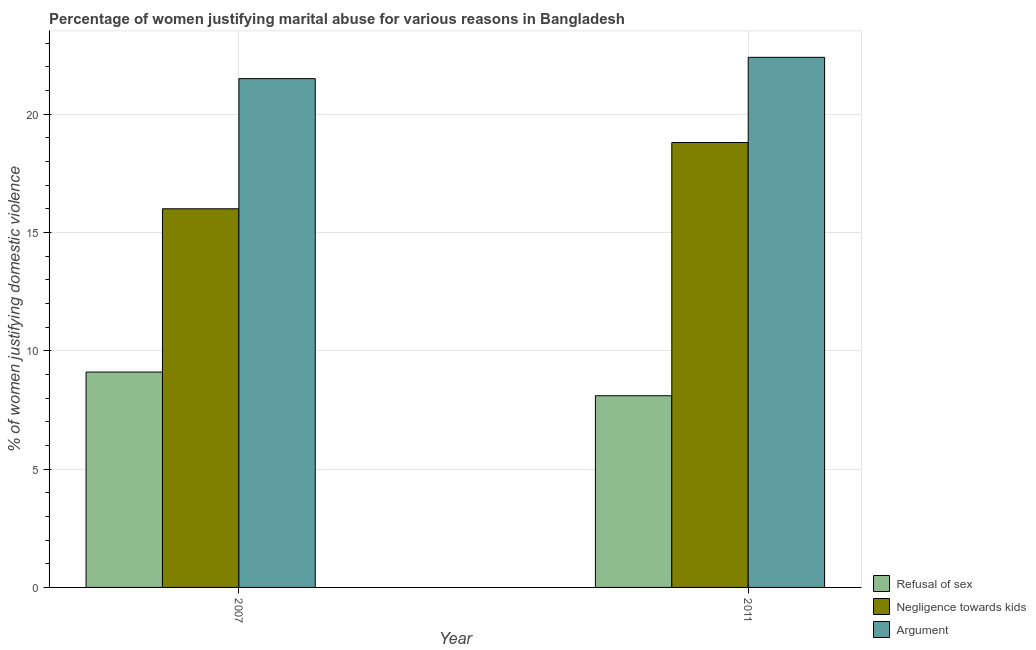How many different coloured bars are there?
Keep it short and to the point. 3. Are the number of bars on each tick of the X-axis equal?
Offer a terse response. Yes. What is the percentage of women justifying domestic violence due to arguments in 2007?
Ensure brevity in your answer.  21.5. Across all years, what is the maximum percentage of women justifying domestic violence due to arguments?
Keep it short and to the point. 22.4. Across all years, what is the minimum percentage of women justifying domestic violence due to negligence towards kids?
Your response must be concise. 16. In which year was the percentage of women justifying domestic violence due to refusal of sex maximum?
Offer a terse response. 2007. In which year was the percentage of women justifying domestic violence due to arguments minimum?
Keep it short and to the point. 2007. What is the total percentage of women justifying domestic violence due to negligence towards kids in the graph?
Give a very brief answer. 34.8. What is the difference between the percentage of women justifying domestic violence due to arguments in 2007 and that in 2011?
Your answer should be compact. -0.9. What is the difference between the percentage of women justifying domestic violence due to arguments in 2007 and the percentage of women justifying domestic violence due to negligence towards kids in 2011?
Your response must be concise. -0.9. In how many years, is the percentage of women justifying domestic violence due to negligence towards kids greater than 1 %?
Your answer should be very brief. 2. What is the ratio of the percentage of women justifying domestic violence due to refusal of sex in 2007 to that in 2011?
Provide a short and direct response. 1.12. Is the percentage of women justifying domestic violence due to negligence towards kids in 2007 less than that in 2011?
Offer a very short reply. Yes. What does the 3rd bar from the left in 2011 represents?
Ensure brevity in your answer.  Argument. What does the 1st bar from the right in 2011 represents?
Your answer should be very brief. Argument. How many bars are there?
Your response must be concise. 6. How many years are there in the graph?
Give a very brief answer. 2. What is the difference between two consecutive major ticks on the Y-axis?
Provide a succinct answer. 5. Are the values on the major ticks of Y-axis written in scientific E-notation?
Keep it short and to the point. No. Does the graph contain grids?
Make the answer very short. Yes. What is the title of the graph?
Offer a terse response. Percentage of women justifying marital abuse for various reasons in Bangladesh. Does "Female employers" appear as one of the legend labels in the graph?
Your answer should be compact. No. What is the label or title of the Y-axis?
Make the answer very short. % of women justifying domestic violence. What is the % of women justifying domestic violence in Negligence towards kids in 2007?
Ensure brevity in your answer.  16. What is the % of women justifying domestic violence in Argument in 2007?
Give a very brief answer. 21.5. What is the % of women justifying domestic violence in Argument in 2011?
Provide a succinct answer. 22.4. Across all years, what is the maximum % of women justifying domestic violence of Argument?
Your response must be concise. 22.4. Across all years, what is the minimum % of women justifying domestic violence in Refusal of sex?
Provide a short and direct response. 8.1. What is the total % of women justifying domestic violence in Negligence towards kids in the graph?
Make the answer very short. 34.8. What is the total % of women justifying domestic violence in Argument in the graph?
Give a very brief answer. 43.9. What is the difference between the % of women justifying domestic violence of Refusal of sex in 2007 and that in 2011?
Your answer should be very brief. 1. What is the difference between the % of women justifying domestic violence in Negligence towards kids in 2007 and that in 2011?
Keep it short and to the point. -2.8. What is the difference between the % of women justifying domestic violence of Argument in 2007 and that in 2011?
Provide a short and direct response. -0.9. What is the difference between the % of women justifying domestic violence in Refusal of sex in 2007 and the % of women justifying domestic violence in Negligence towards kids in 2011?
Keep it short and to the point. -9.7. What is the difference between the % of women justifying domestic violence of Negligence towards kids in 2007 and the % of women justifying domestic violence of Argument in 2011?
Provide a succinct answer. -6.4. What is the average % of women justifying domestic violence in Refusal of sex per year?
Keep it short and to the point. 8.6. What is the average % of women justifying domestic violence in Negligence towards kids per year?
Make the answer very short. 17.4. What is the average % of women justifying domestic violence in Argument per year?
Keep it short and to the point. 21.95. In the year 2007, what is the difference between the % of women justifying domestic violence in Refusal of sex and % of women justifying domestic violence in Argument?
Make the answer very short. -12.4. In the year 2007, what is the difference between the % of women justifying domestic violence in Negligence towards kids and % of women justifying domestic violence in Argument?
Your answer should be very brief. -5.5. In the year 2011, what is the difference between the % of women justifying domestic violence of Refusal of sex and % of women justifying domestic violence of Argument?
Keep it short and to the point. -14.3. What is the ratio of the % of women justifying domestic violence in Refusal of sex in 2007 to that in 2011?
Provide a succinct answer. 1.12. What is the ratio of the % of women justifying domestic violence in Negligence towards kids in 2007 to that in 2011?
Your answer should be compact. 0.85. What is the ratio of the % of women justifying domestic violence in Argument in 2007 to that in 2011?
Your answer should be very brief. 0.96. 